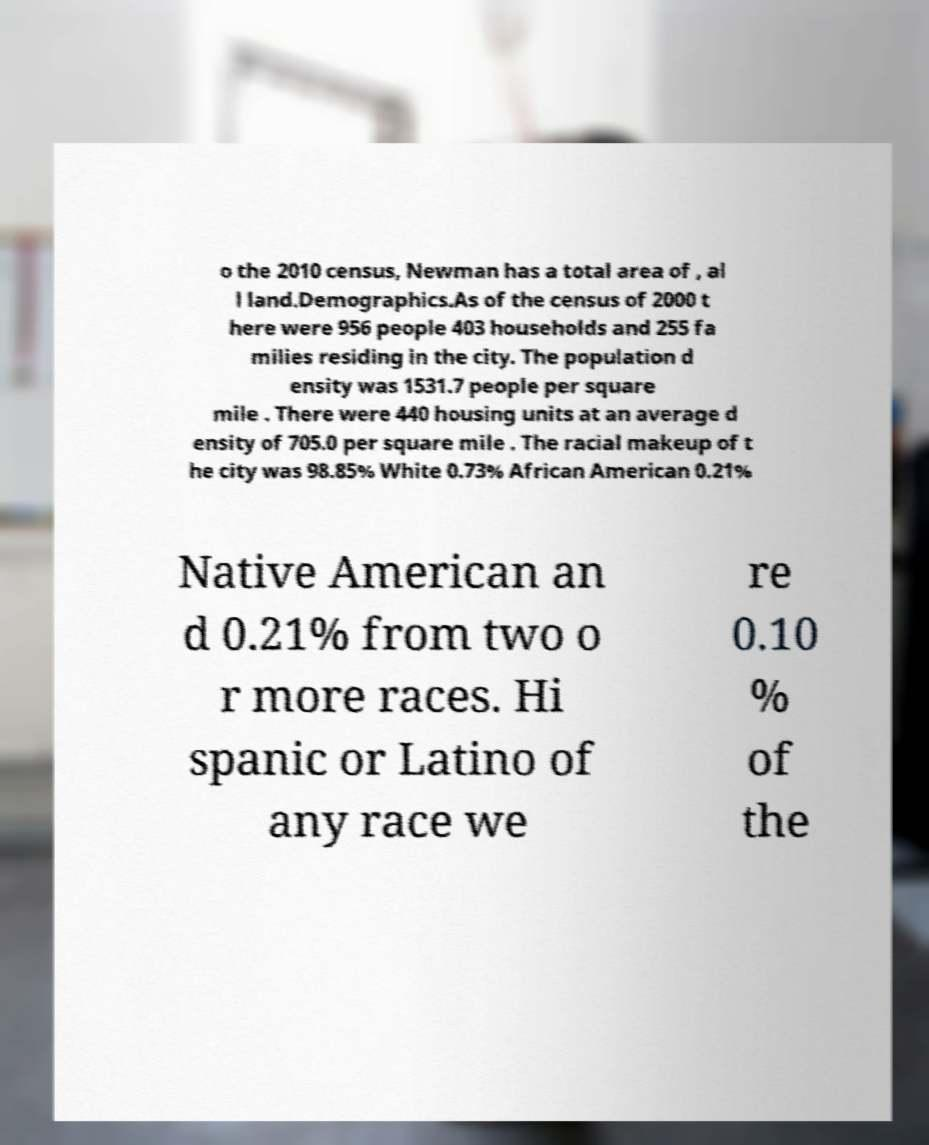For documentation purposes, I need the text within this image transcribed. Could you provide that? o the 2010 census, Newman has a total area of , al l land.Demographics.As of the census of 2000 t here were 956 people 403 households and 255 fa milies residing in the city. The population d ensity was 1531.7 people per square mile . There were 440 housing units at an average d ensity of 705.0 per square mile . The racial makeup of t he city was 98.85% White 0.73% African American 0.21% Native American an d 0.21% from two o r more races. Hi spanic or Latino of any race we re 0.10 % of the 